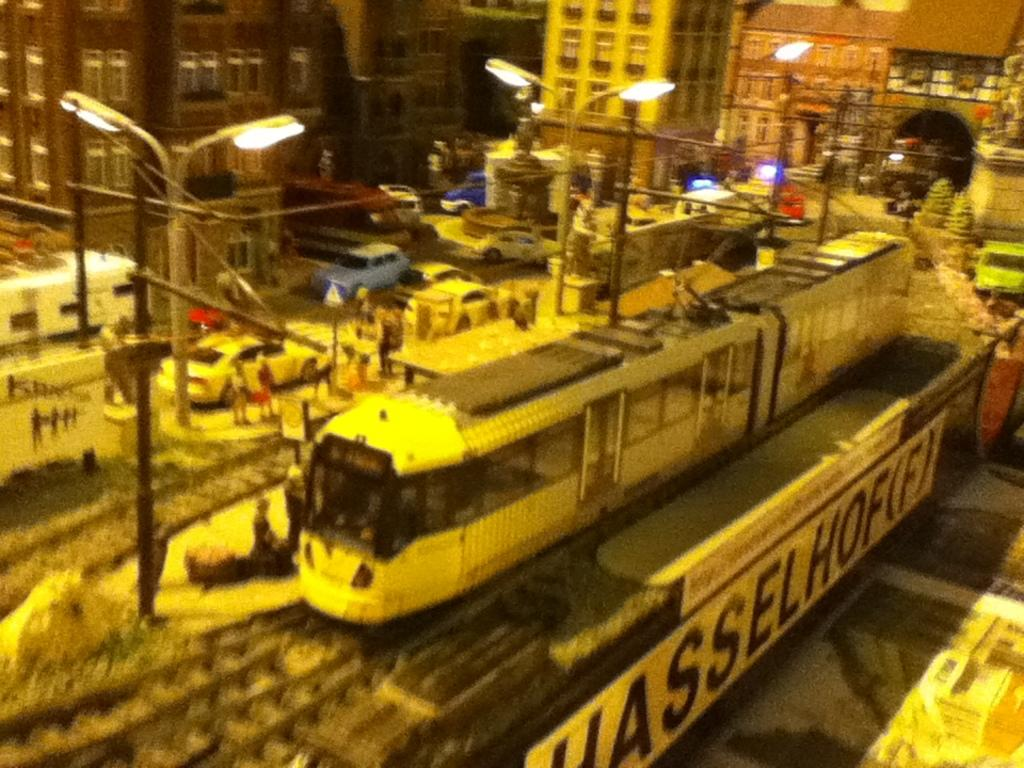<image>
Offer a succinct explanation of the picture presented. A train is going by a fence that has a banner that says Hasselhoff. 